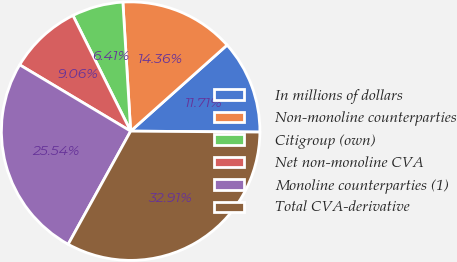Convert chart. <chart><loc_0><loc_0><loc_500><loc_500><pie_chart><fcel>In millions of dollars<fcel>Non-monoline counterparties<fcel>Citigroup (own)<fcel>Net non-monoline CVA<fcel>Monoline counterparties (1)<fcel>Total CVA-derivative<nl><fcel>11.71%<fcel>14.36%<fcel>6.41%<fcel>9.06%<fcel>25.54%<fcel>32.91%<nl></chart> 